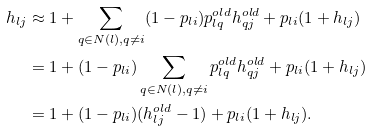<formula> <loc_0><loc_0><loc_500><loc_500>h _ { l j } & \approx 1 + \sum _ { q \in N ( l ) , q \neq i } ( 1 - p _ { l i } ) p _ { l q } ^ { o l d } h _ { q j } ^ { o l d } + p _ { l i } ( 1 + h _ { l j } ) \\ & = 1 + ( 1 - p _ { l i } ) \sum _ { q \in N ( l ) , q \neq i } p _ { l q } ^ { o l d } h _ { q j } ^ { o l d } + p _ { l i } ( 1 + h _ { l j } ) \\ & = 1 + ( 1 - p _ { l i } ) ( h _ { l j } ^ { o l d } - 1 ) + p _ { l i } ( 1 + h _ { l j } ) .</formula> 